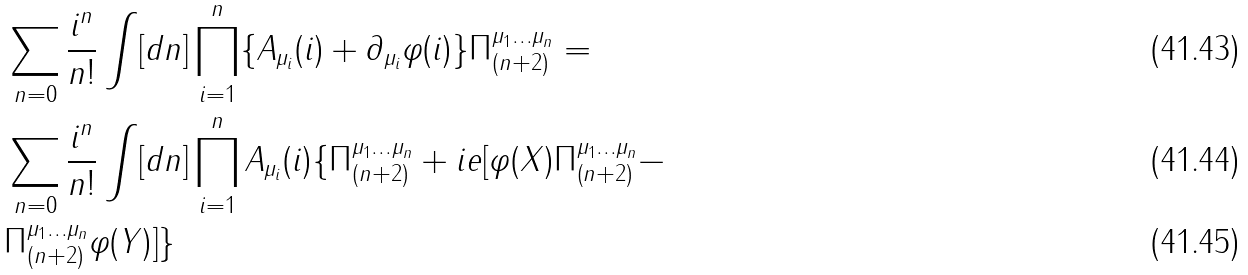Convert formula to latex. <formula><loc_0><loc_0><loc_500><loc_500>& \sum _ { n = 0 } \frac { i ^ { n } } { n ! } \int [ d n ] \prod _ { i = 1 } ^ { n } \{ A _ { \mu _ { i } } ( i ) + \partial _ { \mu _ { i } } \varphi ( i ) \} \Pi _ { ( n + 2 ) } ^ { \mu _ { 1 } \dots \mu _ { n } } = \\ & \sum _ { n = 0 } \frac { i ^ { n } } { n ! } \int [ d n ] \prod _ { i = 1 } ^ { n } A _ { \mu _ { i } } ( i ) \{ \Pi _ { ( n + 2 ) } ^ { \mu _ { 1 } \dots \mu _ { n } } + i e [ \varphi ( X ) \Pi _ { ( n + 2 ) } ^ { \mu _ { 1 } \dots \mu _ { n } } - \\ & \Pi _ { ( n + 2 ) } ^ { \mu _ { 1 } \dots \mu _ { n } } \varphi ( Y ) ] \}</formula> 